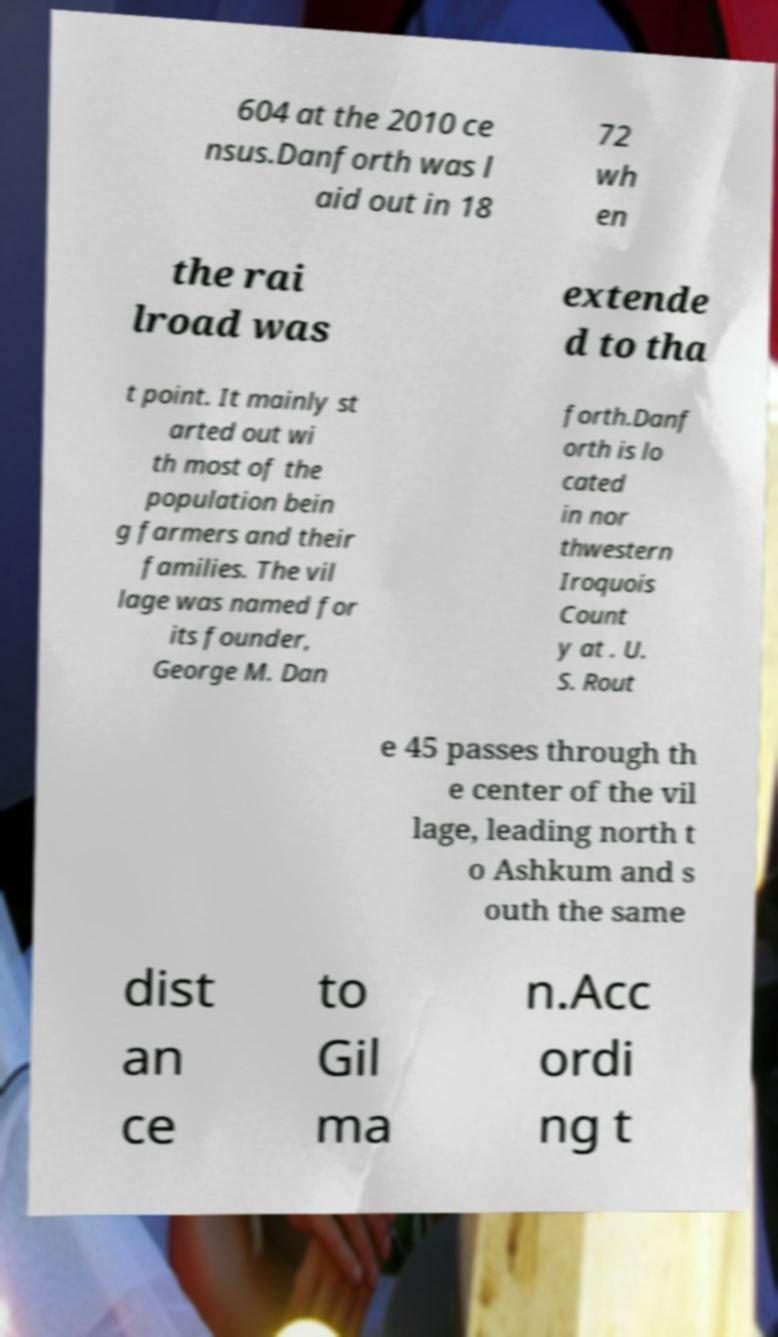What messages or text are displayed in this image? I need them in a readable, typed format. 604 at the 2010 ce nsus.Danforth was l aid out in 18 72 wh en the rai lroad was extende d to tha t point. It mainly st arted out wi th most of the population bein g farmers and their families. The vil lage was named for its founder, George M. Dan forth.Danf orth is lo cated in nor thwestern Iroquois Count y at . U. S. Rout e 45 passes through th e center of the vil lage, leading north t o Ashkum and s outh the same dist an ce to Gil ma n.Acc ordi ng t 